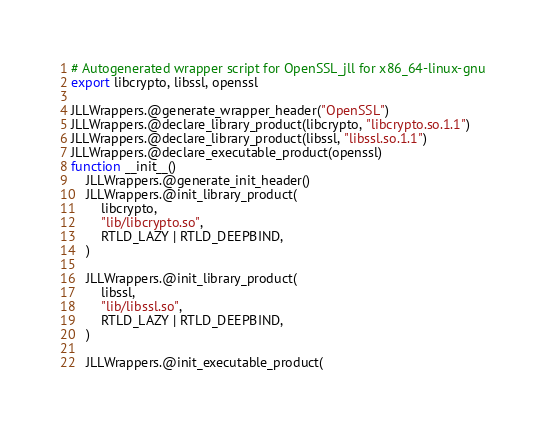<code> <loc_0><loc_0><loc_500><loc_500><_Julia_># Autogenerated wrapper script for OpenSSL_jll for x86_64-linux-gnu
export libcrypto, libssl, openssl

JLLWrappers.@generate_wrapper_header("OpenSSL")
JLLWrappers.@declare_library_product(libcrypto, "libcrypto.so.1.1")
JLLWrappers.@declare_library_product(libssl, "libssl.so.1.1")
JLLWrappers.@declare_executable_product(openssl)
function __init__()
    JLLWrappers.@generate_init_header()
    JLLWrappers.@init_library_product(
        libcrypto,
        "lib/libcrypto.so",
        RTLD_LAZY | RTLD_DEEPBIND,
    )

    JLLWrappers.@init_library_product(
        libssl,
        "lib/libssl.so",
        RTLD_LAZY | RTLD_DEEPBIND,
    )

    JLLWrappers.@init_executable_product(</code> 